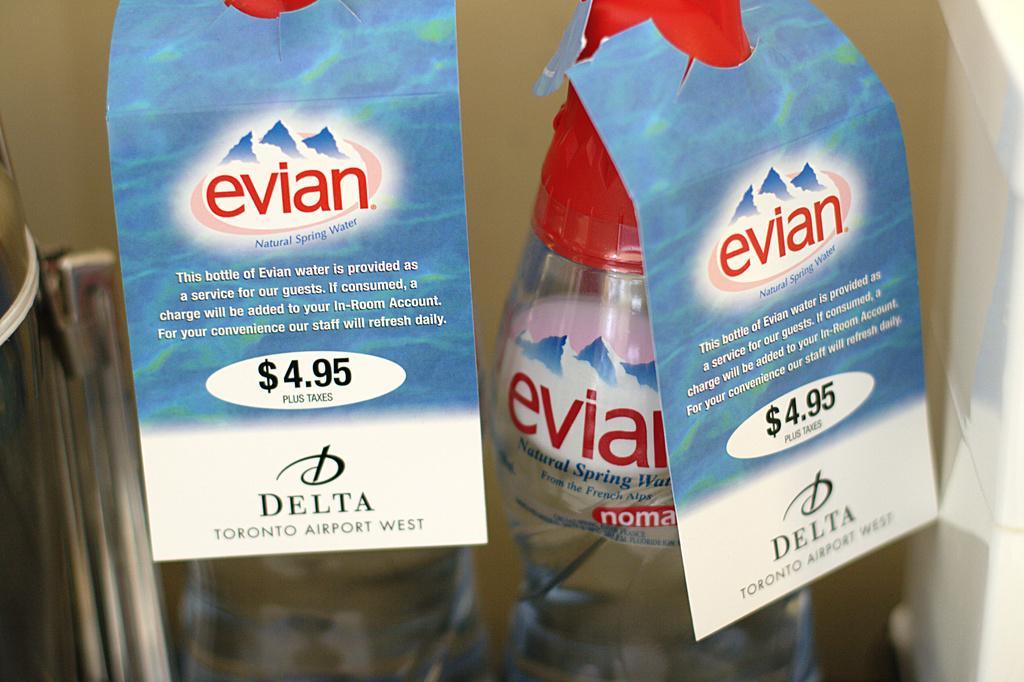In one or two sentences, can you explain what this image depicts? In this Image I see the bottles and there are price tags on it 